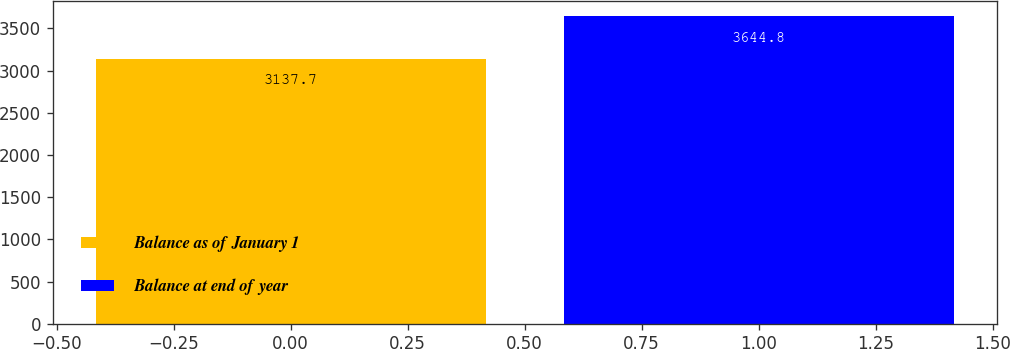<chart> <loc_0><loc_0><loc_500><loc_500><bar_chart><fcel>Balance as of January 1<fcel>Balance at end of year<nl><fcel>3137.7<fcel>3644.8<nl></chart> 